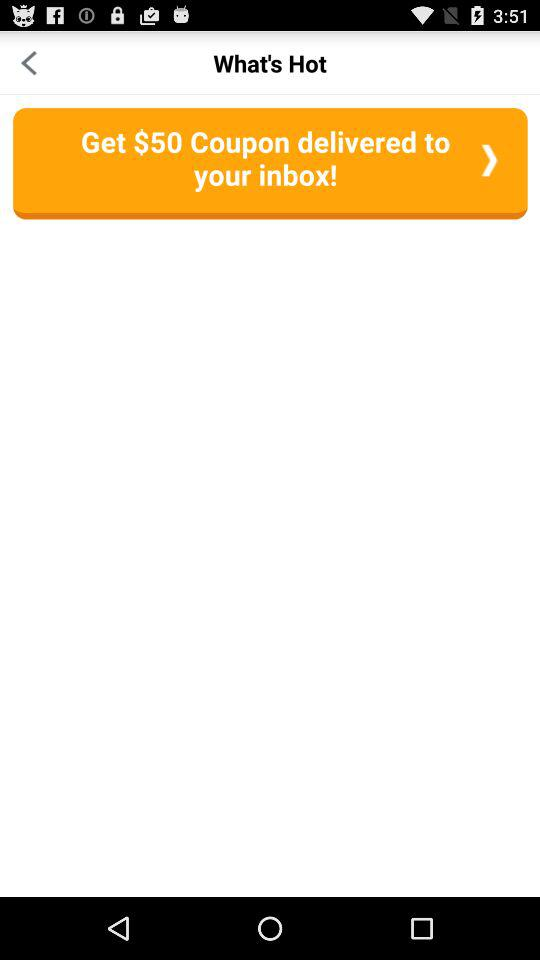How many items have a heart next to them?
Answer the question using a single word or phrase. 2 